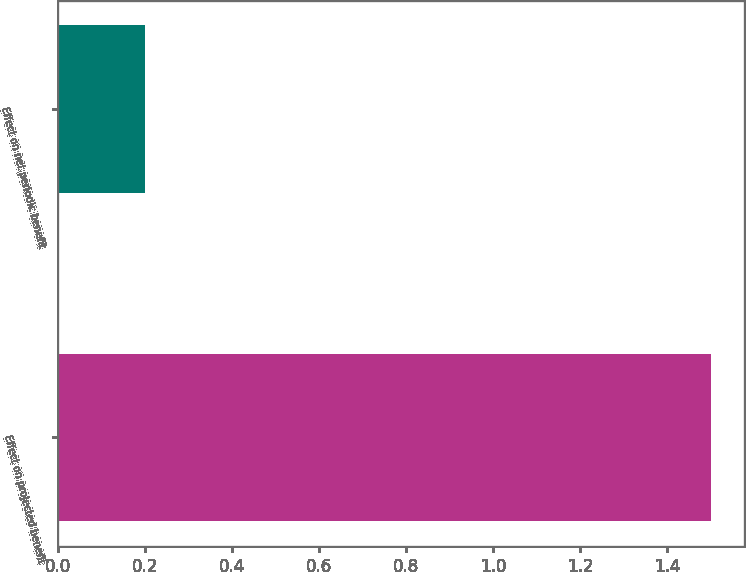Convert chart. <chart><loc_0><loc_0><loc_500><loc_500><bar_chart><fcel>Effect on projected benefit<fcel>Effect on net periodic benefit<nl><fcel>1.5<fcel>0.2<nl></chart> 